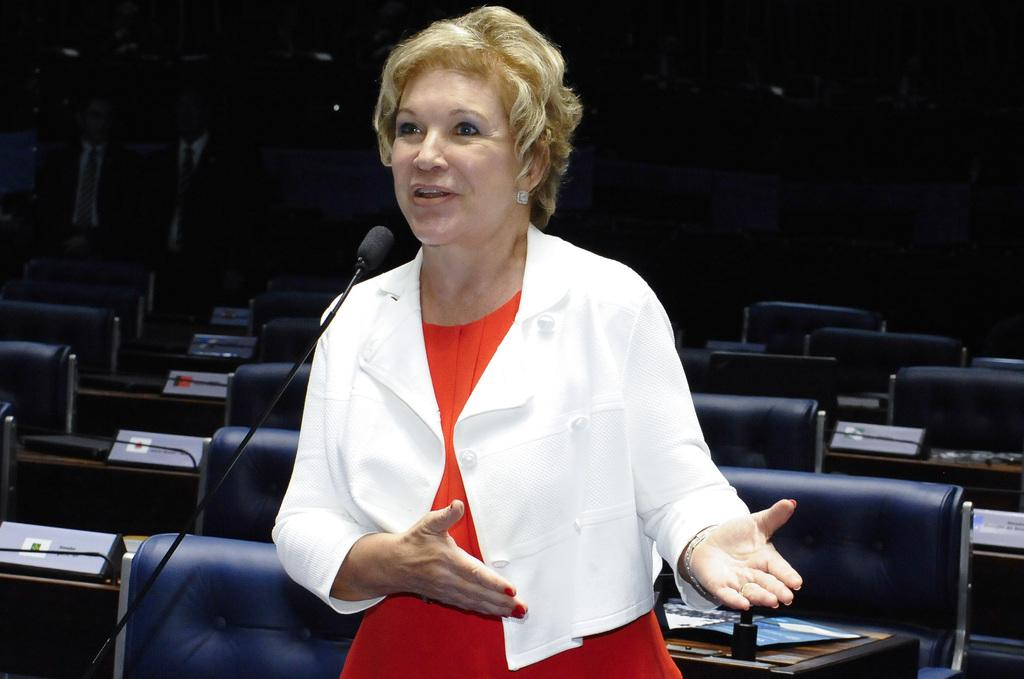Who is the main subject in the image? There is a lady in the image. What is the lady wearing? The lady is wearing a white jacket. What object is in front of the lady? There is a microphone in front of the lady. What can be seen in the background of the image? There are chairs and tables in the background of the image. How many hens are sitting on the tables in the image? There are no hens present in the image; it only features a lady, a microphone, chairs, and tables. What type of line is connecting the chairs in the image? There is no line connecting the chairs in the image; they are simply arranged in the background. 